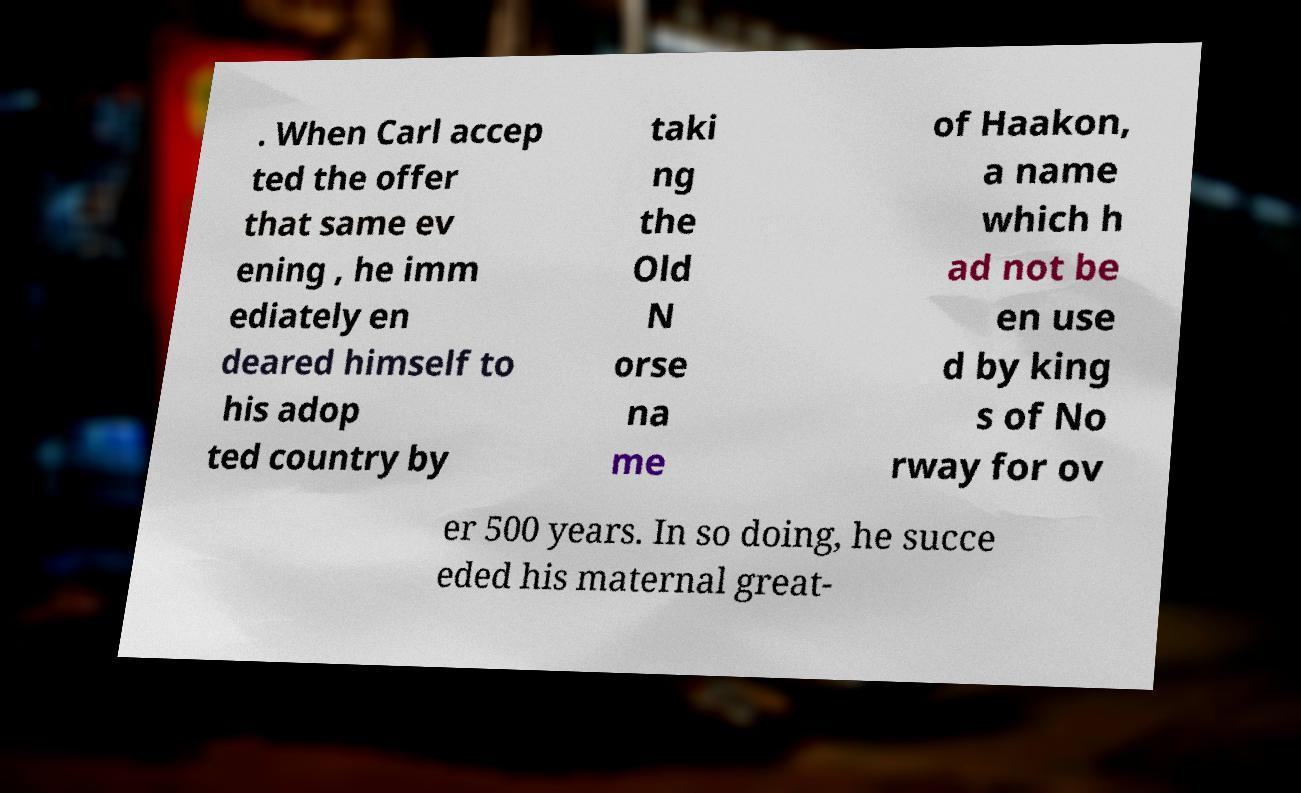Please read and relay the text visible in this image. What does it say? . When Carl accep ted the offer that same ev ening , he imm ediately en deared himself to his adop ted country by taki ng the Old N orse na me of Haakon, a name which h ad not be en use d by king s of No rway for ov er 500 years. In so doing, he succe eded his maternal great- 